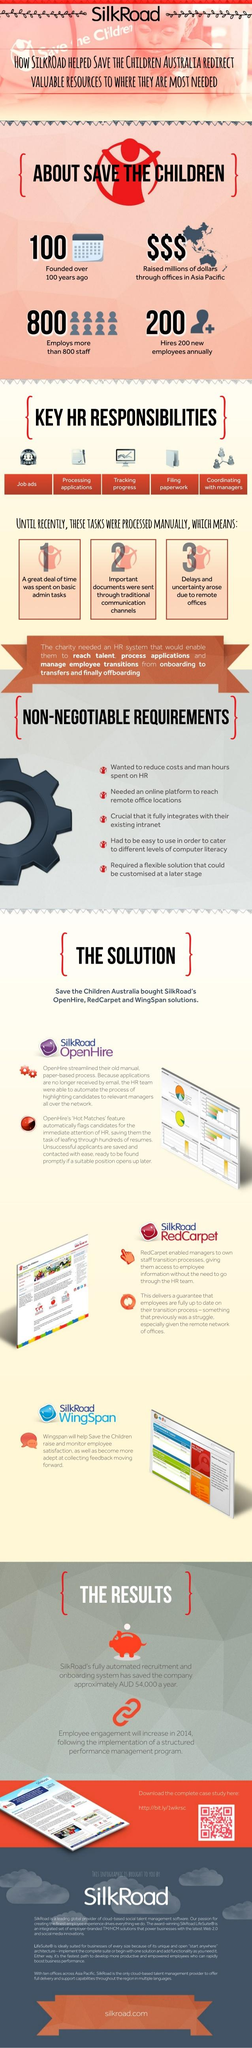Give some essential details in this illustration. The infographic lists five HR responsibilities. I declare that there are five points under the heading "Non-Negotiable Requirements". 